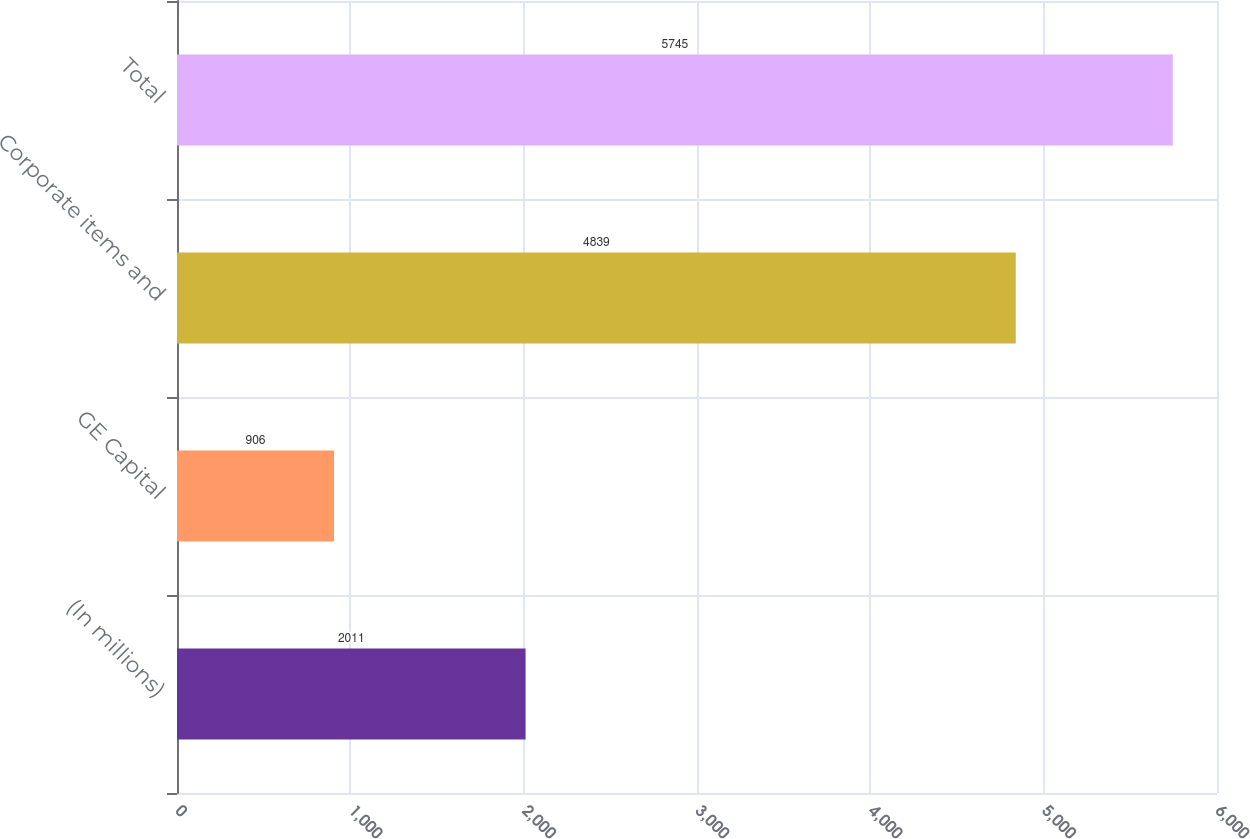<chart> <loc_0><loc_0><loc_500><loc_500><bar_chart><fcel>(In millions)<fcel>GE Capital<fcel>Corporate items and<fcel>Total<nl><fcel>2011<fcel>906<fcel>4839<fcel>5745<nl></chart> 